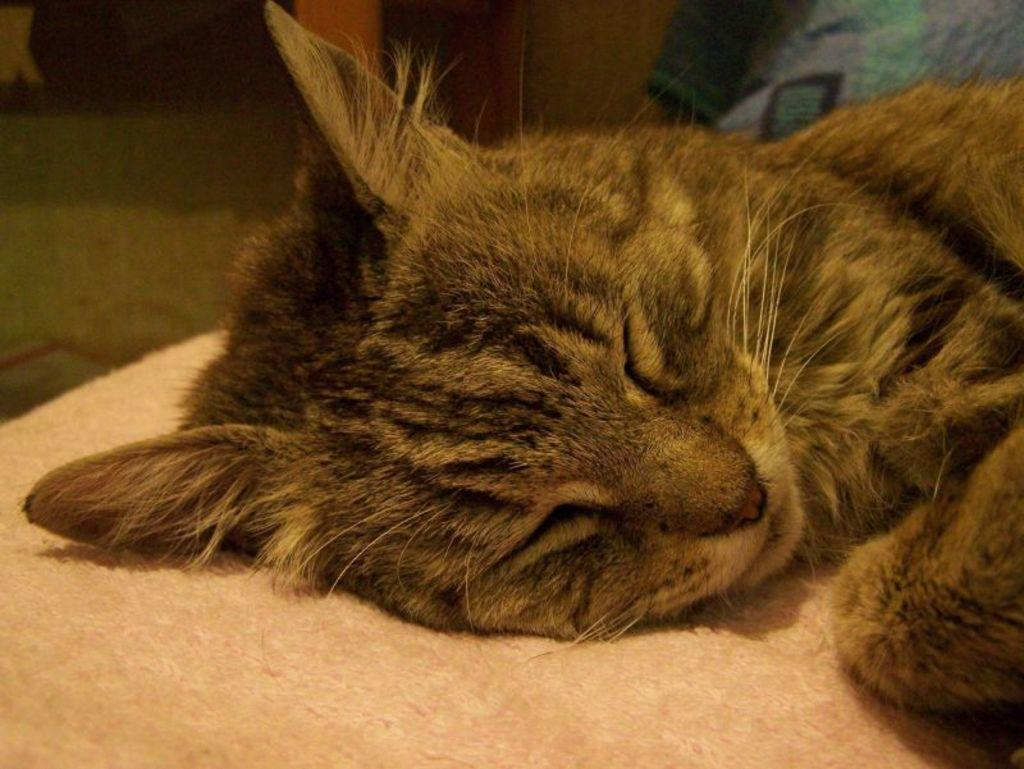What type of animal is present in the image? There is a cat in the picture. What is the cat doing in the image? The cat is lying on a surface. Can you describe the background of the image? There are objects visible in the background of the image. What type of mitten is the fireman wearing in the image? There is no fireman or mitten present in the image; it features a cat lying on a surface. 